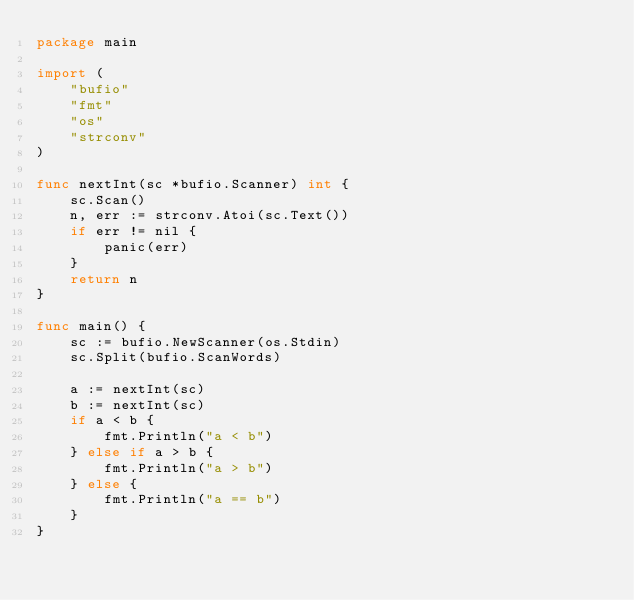Convert code to text. <code><loc_0><loc_0><loc_500><loc_500><_Go_>package main

import (
	"bufio"
	"fmt"
	"os"
	"strconv"
)

func nextInt(sc *bufio.Scanner) int {
	sc.Scan()
	n, err := strconv.Atoi(sc.Text())
	if err != nil {
		panic(err)
	}
	return n
}

func main() {
	sc := bufio.NewScanner(os.Stdin)
	sc.Split(bufio.ScanWords)

	a := nextInt(sc)
	b := nextInt(sc)
	if a < b {
		fmt.Println("a < b")
	} else if a > b {
		fmt.Println("a > b")
	} else {
		fmt.Println("a == b")
	}
}

</code> 